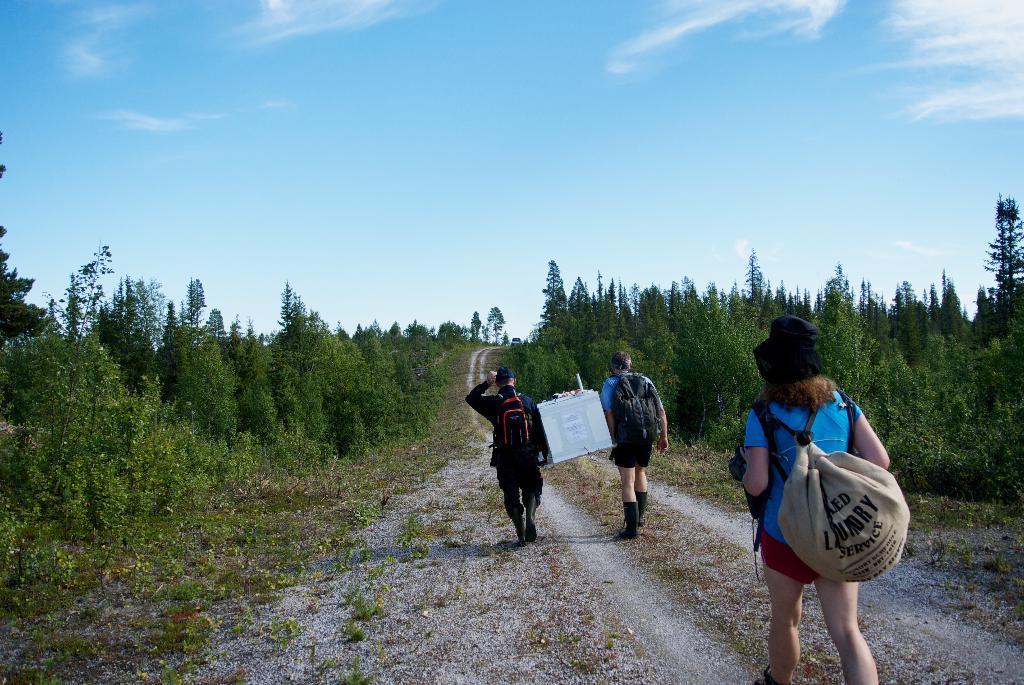Please provide a concise description of this image. This is a image of a woman who is walking in the way by wearing a backpack with black color hat and there are 2 man who are holding some paper and they are walking with backpacks and at the back ground there are trees, plants , car and a sky covered with clouds. 